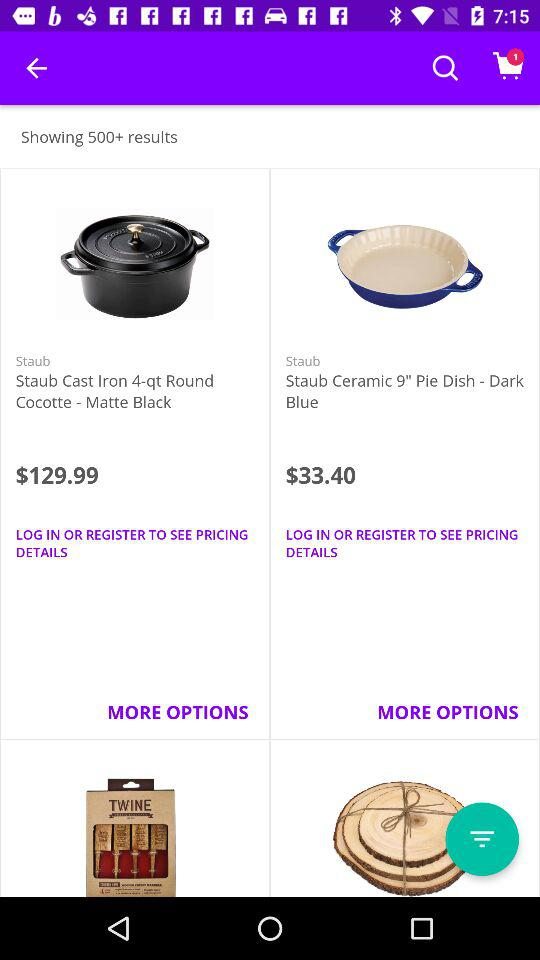What is the price of "Staub Ceramic 9""? The price is $33.40. 